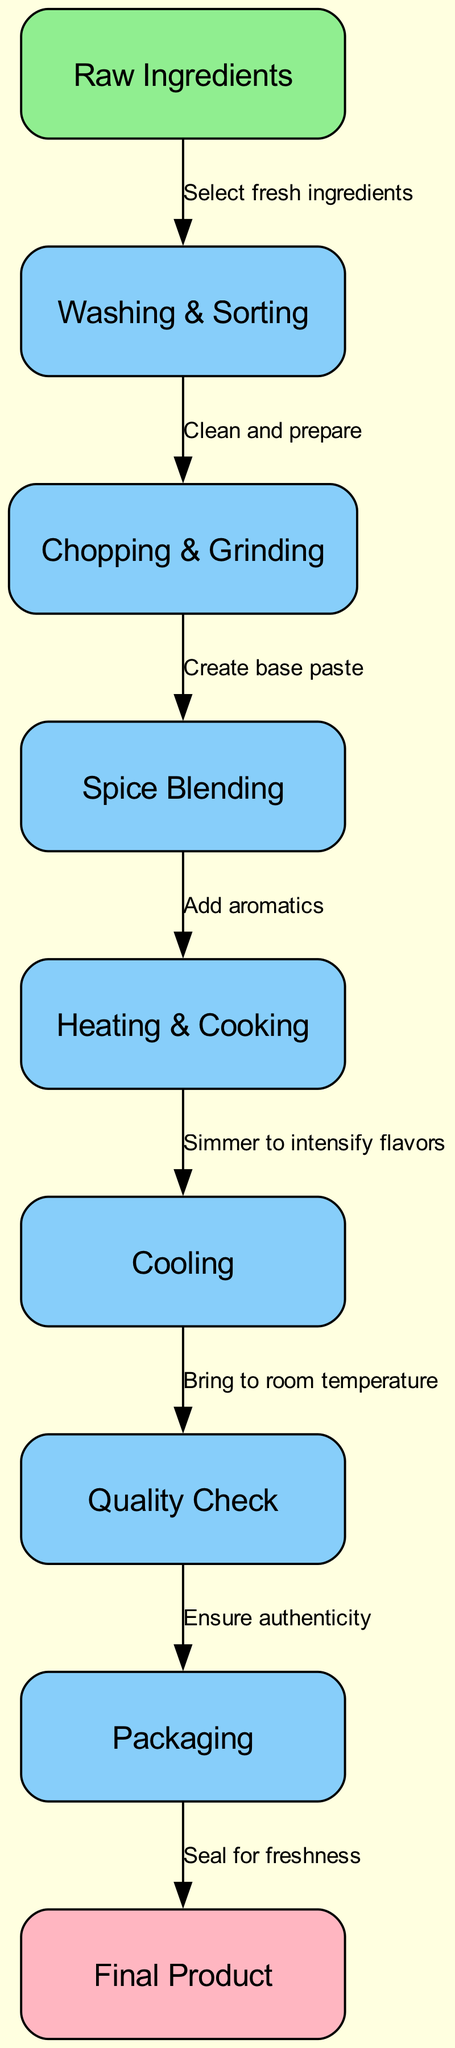What is the first step in the production process? The first step in the production process is to select fresh ingredients, which is indicated by the edge leading from the "Raw Ingredients" node to the "Washing & Sorting" node.
Answer: Select fresh ingredients How many total nodes are there in the diagram? By counting each of the nodes listed, we find that there are 9 nodes total in the diagram.
Answer: 9 What follows "Cooling" in the production process? The next step after "Cooling" is the "Quality Check," as indicated by the flow from the "Cooling" node to the "Quality Check" node.
Answer: Quality Check Which node is colored lightpink? The final product node is colored lightpink, as only the "Final Product" node corresponds to this color scheme in the diagram.
Answer: Final Product What label connects "Spice Blending" and "Heating & Cooking"? The label connecting these two nodes is "Add aromatics," which describes the action taken between them as shown in the edge.
Answer: Add aromatics What is the purpose of the edge leading from "Quality Check" to "Packaging"? The edge from "Quality Check" to "Packaging" is labeled "Ensure authenticity," indicating the quality assurance protocol before packaging.
Answer: Ensure authenticity How many edges are there in the diagram? By counting each directed connection (edge) between nodes, we see that there are a total of 8 edges in the diagram.
Answer: 8 What is the last step before the product is sealed? The last step before sealing the product is the "Quality Check" stage as per the flow leading to the "Packaging" node.
Answer: Quality Check Which step involves bringing the mixture to room temperature? The step that involves bringing the mixture to room temperature is the "Cooling" step, as defined by the edges in the production process.
Answer: Cooling 